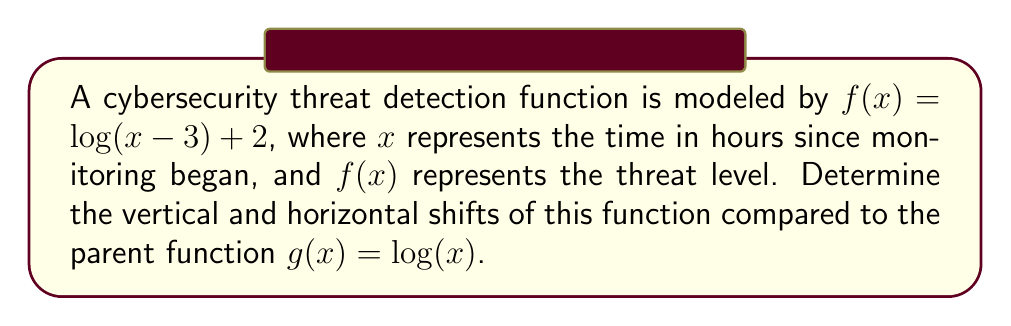Show me your answer to this math problem. To determine the vertical and horizontal shifts of the given function, we need to compare it to its parent function. Let's break this down step-by-step:

1. The parent function is $g(x) = \log(x)$.

2. The given function is $f(x) = \log(x - 3) + 2$.

3. To identify the horizontal shift:
   - Look at what's inside the parentheses: $(x - 3)$
   - This indicates a horizontal shift of 3 units to the right
   - The general form for a horizontal shift is $\log(x - h)$, where $h$ is the number of units shifted right

4. To identify the vertical shift:
   - Look at what's added outside the logarithm: $+ 2$
   - This indicates a vertical shift of 2 units up
   - The general form for a vertical shift is $\log(x) + k$, where $k$ is the number of units shifted up

5. Putting it all together:
   - $f(x) = \log(x - 3) + 2$ represents:
     - A horizontal shift of 3 units right
     - A vertical shift of 2 units up

This transformation allows the cybersecurity threat detection function to adjust its baseline (vertical shift) and account for a delay in threat manifestation (horizontal shift).
Answer: The function $f(x) = \log(x - 3) + 2$ has a horizontal shift of 3 units right and a vertical shift of 2 units up compared to the parent function $g(x) = \log(x)$. 